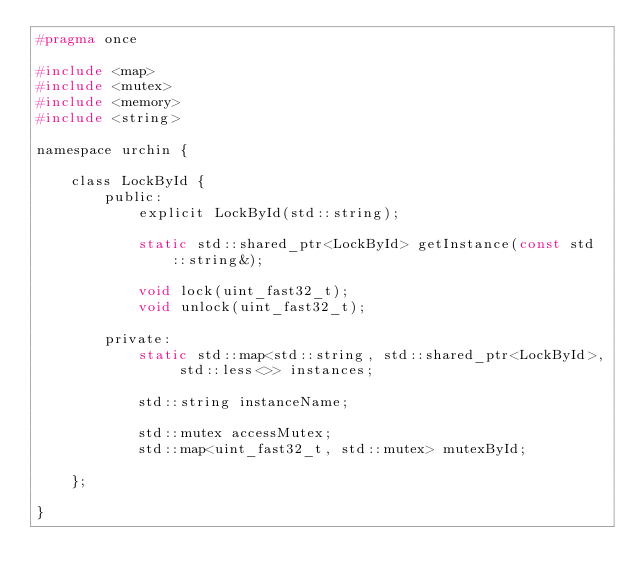<code> <loc_0><loc_0><loc_500><loc_500><_C_>#pragma once

#include <map>
#include <mutex>
#include <memory>
#include <string>

namespace urchin {

    class LockById {
        public:
            explicit LockById(std::string);

            static std::shared_ptr<LockById> getInstance(const std::string&);

            void lock(uint_fast32_t);
            void unlock(uint_fast32_t);

        private:
            static std::map<std::string, std::shared_ptr<LockById>, std::less<>> instances;

            std::string instanceName;

            std::mutex accessMutex;
            std::map<uint_fast32_t, std::mutex> mutexById;

    };

}
</code> 